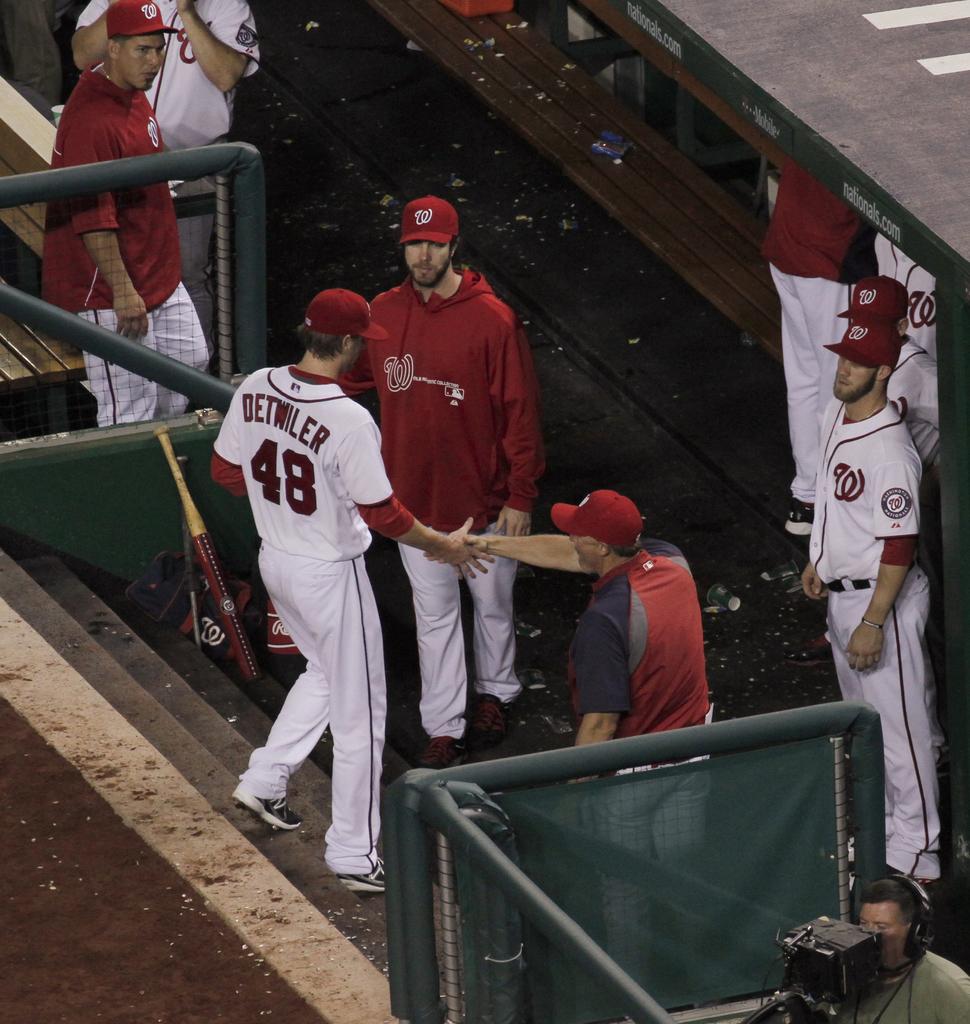What number is on the jersey?
Provide a succinct answer. 48. 